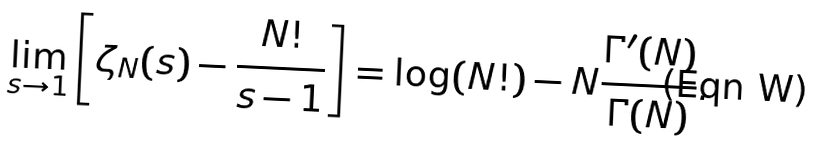Convert formula to latex. <formula><loc_0><loc_0><loc_500><loc_500>\lim _ { s \rightarrow 1 } \left [ \zeta _ { N } ( s ) - \frac { N ! } { s - 1 } \right ] = \log ( N ! ) - N \frac { \Gamma ^ { \prime } ( N ) } { \Gamma ( N ) } .</formula> 